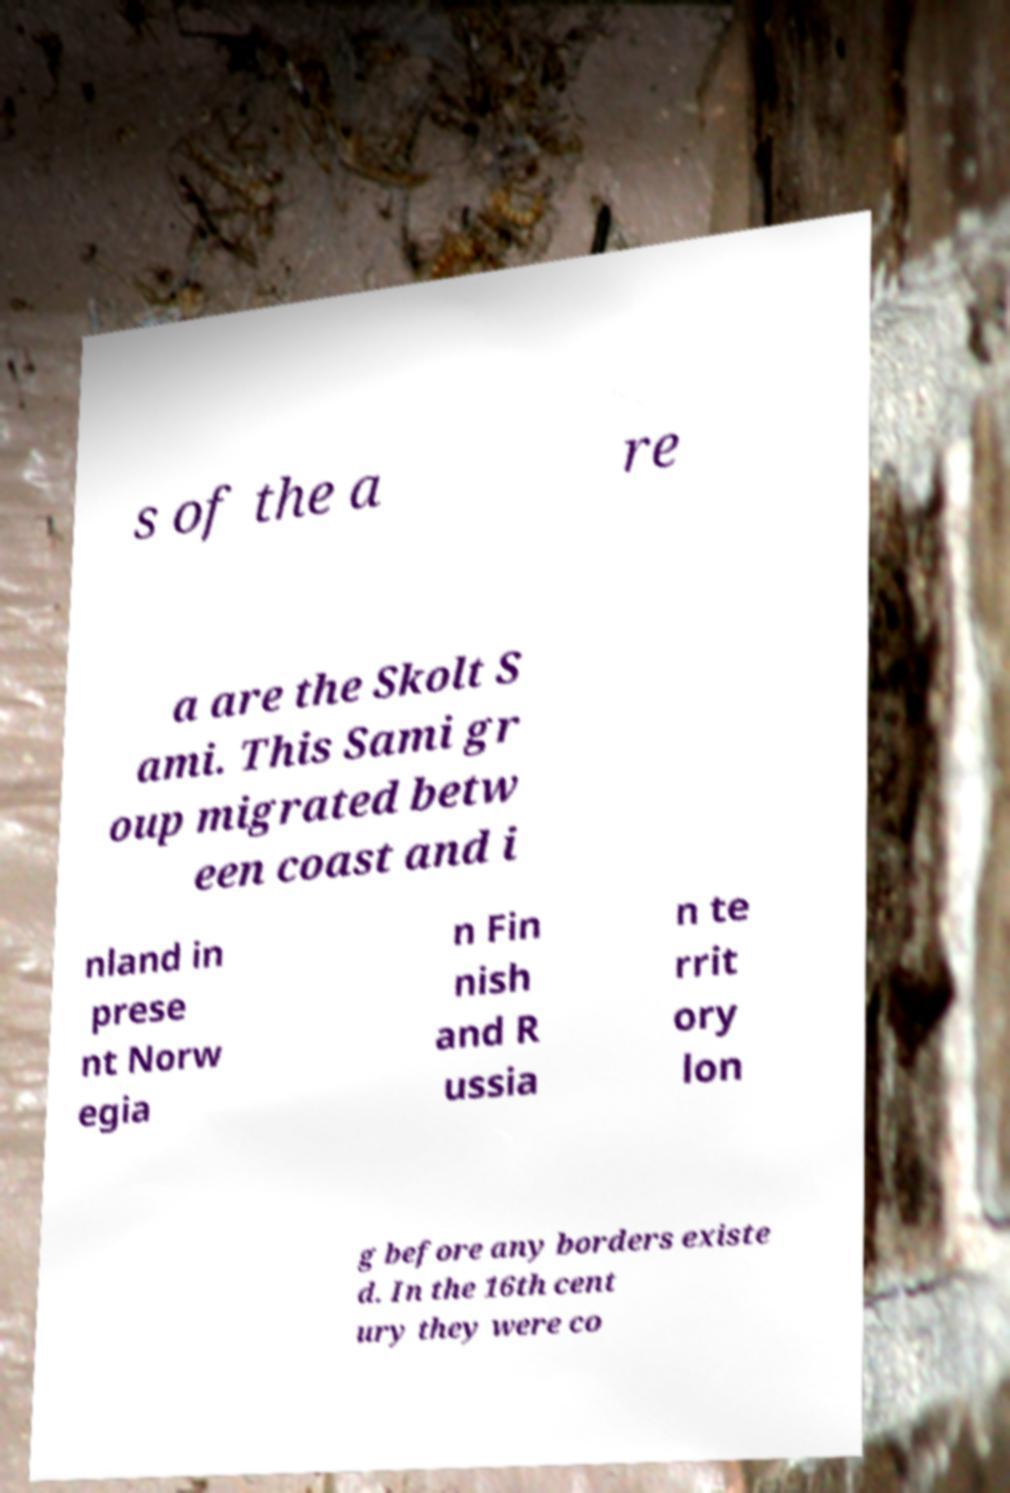Could you assist in decoding the text presented in this image and type it out clearly? s of the a re a are the Skolt S ami. This Sami gr oup migrated betw een coast and i nland in prese nt Norw egia n Fin nish and R ussia n te rrit ory lon g before any borders existe d. In the 16th cent ury they were co 